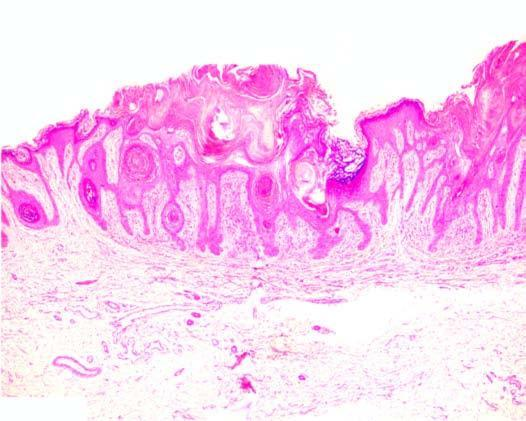what do the other features include?
Answer the question using a single word or phrase. Papillomatosis 